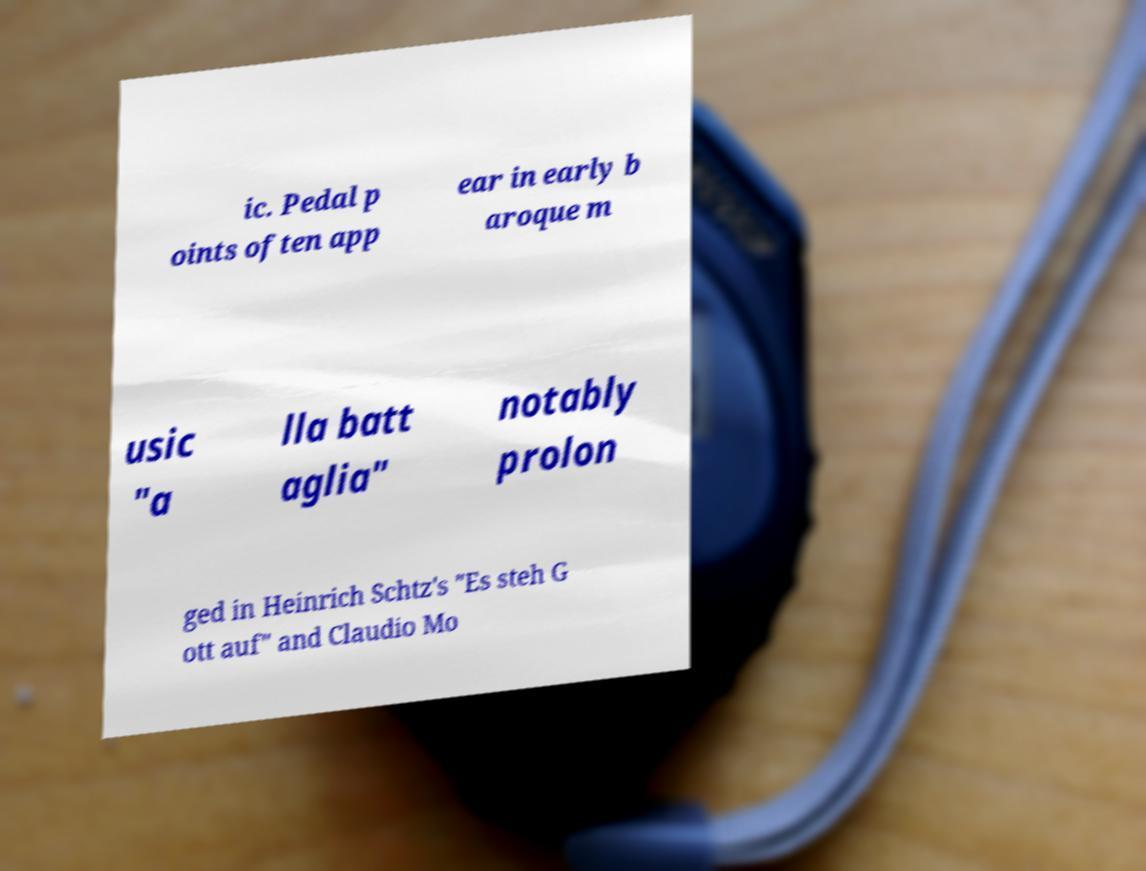Can you accurately transcribe the text from the provided image for me? ic. Pedal p oints often app ear in early b aroque m usic "a lla batt aglia" notably prolon ged in Heinrich Schtz's "Es steh G ott auf" and Claudio Mo 